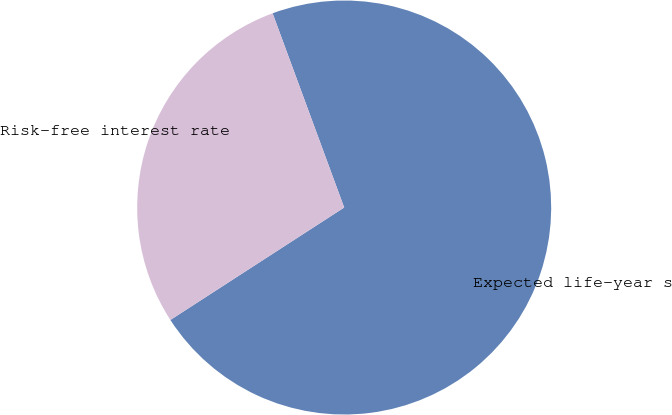Convert chart to OTSL. <chart><loc_0><loc_0><loc_500><loc_500><pie_chart><fcel>Expected life-year s<fcel>Risk-free interest rate<nl><fcel>71.48%<fcel>28.52%<nl></chart> 